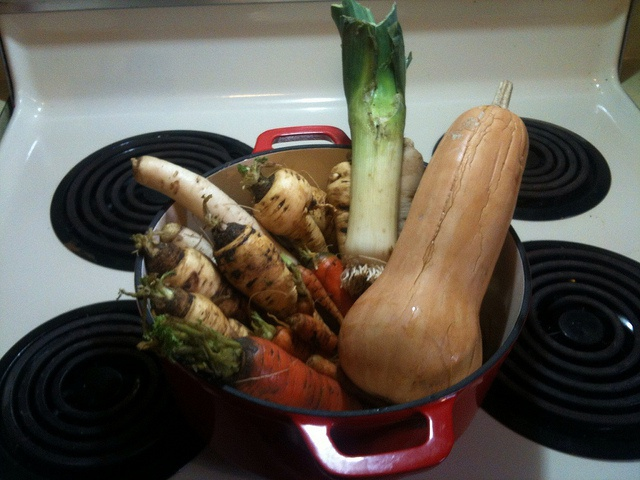Describe the objects in this image and their specific colors. I can see oven in black, darkgray, gray, and lightgray tones, bowl in black, maroon, olive, and gray tones, carrot in black, maroon, and brown tones, carrot in black and maroon tones, and carrot in black, maroon, olive, and brown tones in this image. 